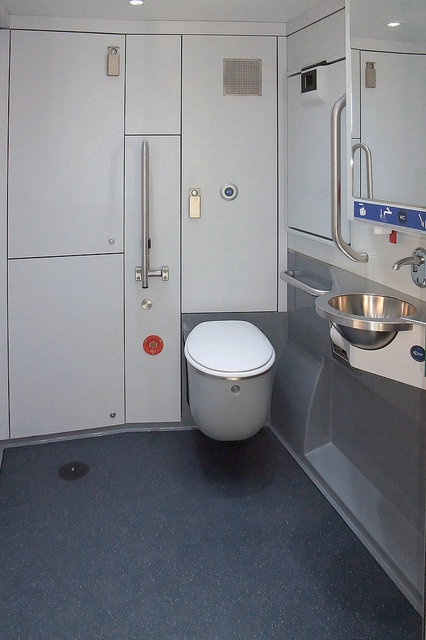Describe the objects in this image and their specific colors. I can see toilet in gray, lightgray, and black tones and sink in gray and black tones in this image. 